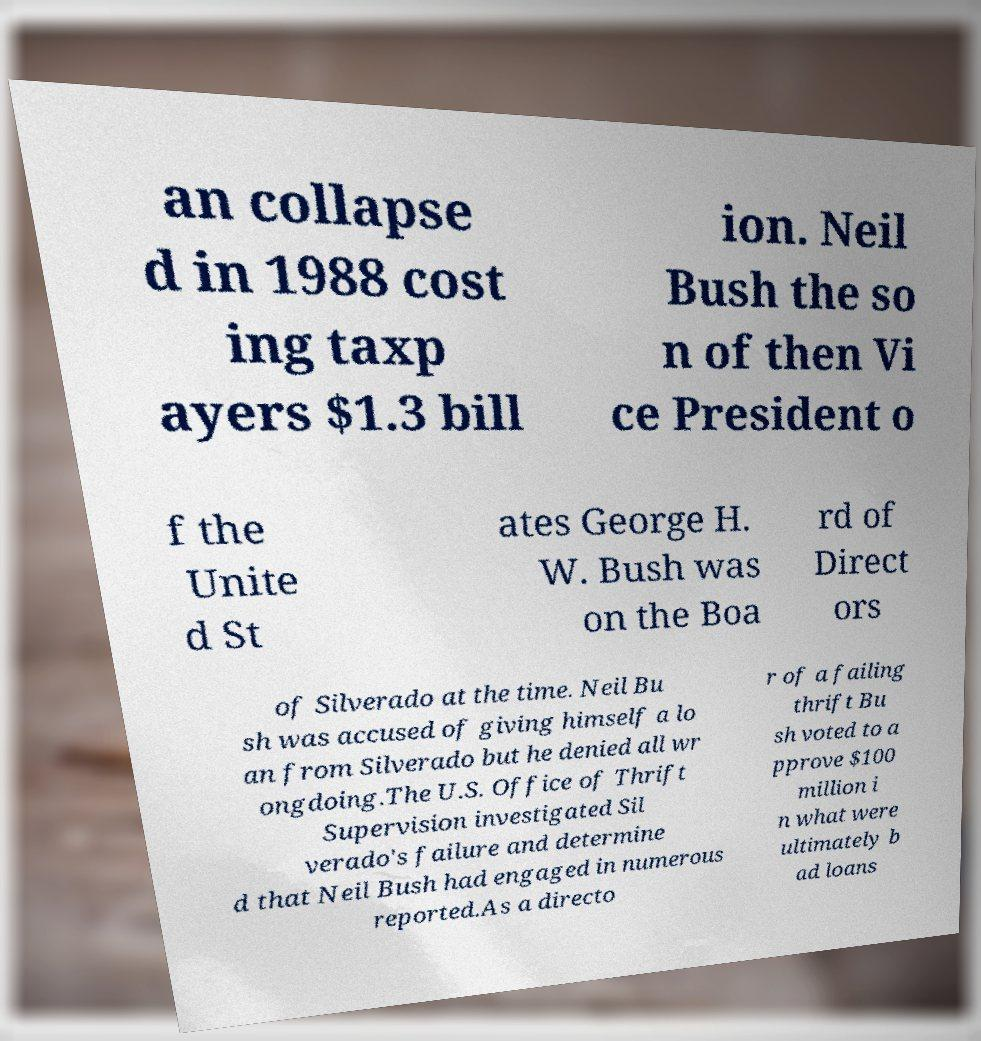What messages or text are displayed in this image? I need them in a readable, typed format. an collapse d in 1988 cost ing taxp ayers $1.3 bill ion. Neil Bush the so n of then Vi ce President o f the Unite d St ates George H. W. Bush was on the Boa rd of Direct ors of Silverado at the time. Neil Bu sh was accused of giving himself a lo an from Silverado but he denied all wr ongdoing.The U.S. Office of Thrift Supervision investigated Sil verado's failure and determine d that Neil Bush had engaged in numerous reported.As a directo r of a failing thrift Bu sh voted to a pprove $100 million i n what were ultimately b ad loans 